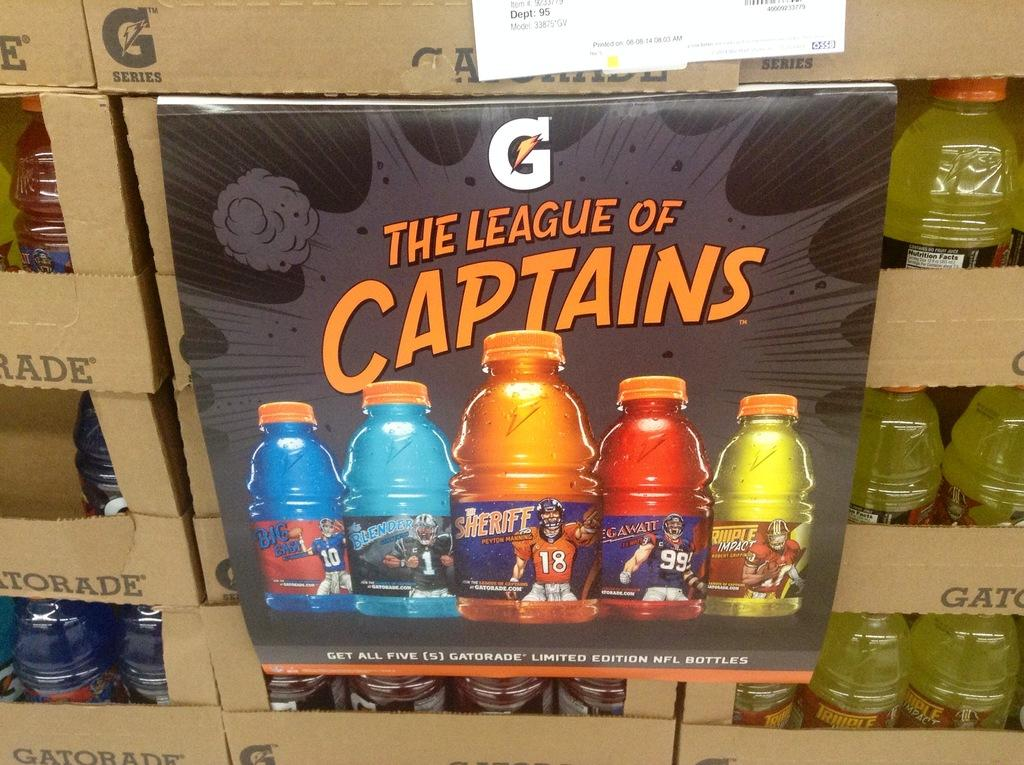<image>
Relay a brief, clear account of the picture shown. A The League of Captains sign is plastered over boxes of Gatorade. 